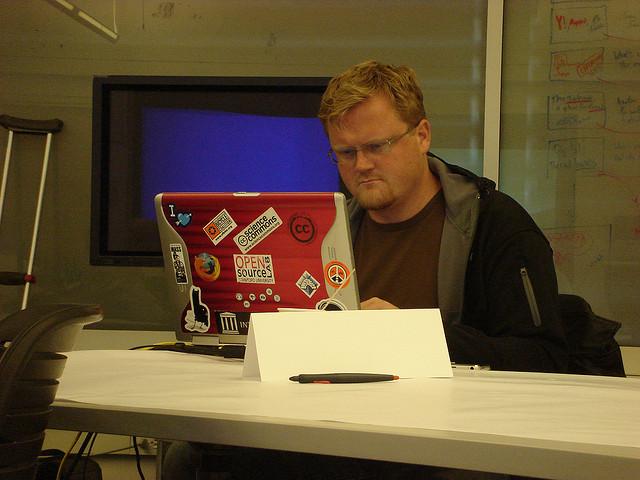How many laptops?
Answer briefly. 1. Is the man wearing glasses?
Quick response, please. Yes. Is this room the kitchen?
Write a very short answer. No. How many people are wearing glasses?
Quick response, please. 1. Does the man look proud?
Answer briefly. No. What is the table made of?
Answer briefly. Plastic. Does he have an injury?
Give a very brief answer. No. What does it say not to do around the computer?
Answer briefly. Open. What game is he playing?
Write a very short answer. Minecraft. How many men are in the photo?
Keep it brief. 1. Is there is a hand in the picture?
Be succinct. Yes. How many men in the photo?
Be succinct. 1. How many laptops are on the white table?
Short answer required. 1. What color is the laptop?
Concise answer only. Red. What kind of computer are they using?
Give a very brief answer. Laptop. Does the man have difficulty reading up close?
Keep it brief. Yes. What material is the table made of?
Short answer required. Plastic. How many wear glasses?
Give a very brief answer. 1. What brand is the laptop?
Keep it brief. Dell. Is there a cookie on the table?
Concise answer only. No. What I kind of computer is he using?
Answer briefly. Laptop. Is he giving a speech?
Give a very brief answer. No. Is that a laptop or a desktop PC?
Write a very short answer. Laptop. What game is shown behind the laptop?
Short answer required. None. How many people at the table?
Be succinct. 1. Does this look like an ad for working at home?
Concise answer only. No. What is attached to the front of the mirror?
Keep it brief. Nothing. Does the man have hair?
Quick response, please. Yes. What is this man fixing?
Give a very brief answer. Laptop. Is the man smiling?
Short answer required. No. What type of laptop computer is that?
Short answer required. Dell. What color is the table?
Quick response, please. White. Are the eye glasses in a case?
Be succinct. No. How many people are there?
Quick response, please. 1. Is there a stuffed animal on his belly?
Give a very brief answer. No. Is there flowers here?
Be succinct. No. How many laptops can be seen?
Be succinct. 1. Which side of the man is visible?
Be succinct. Front. What color is his shirt?
Answer briefly. Brown. What is around this person's neck?
Concise answer only. Collar. 